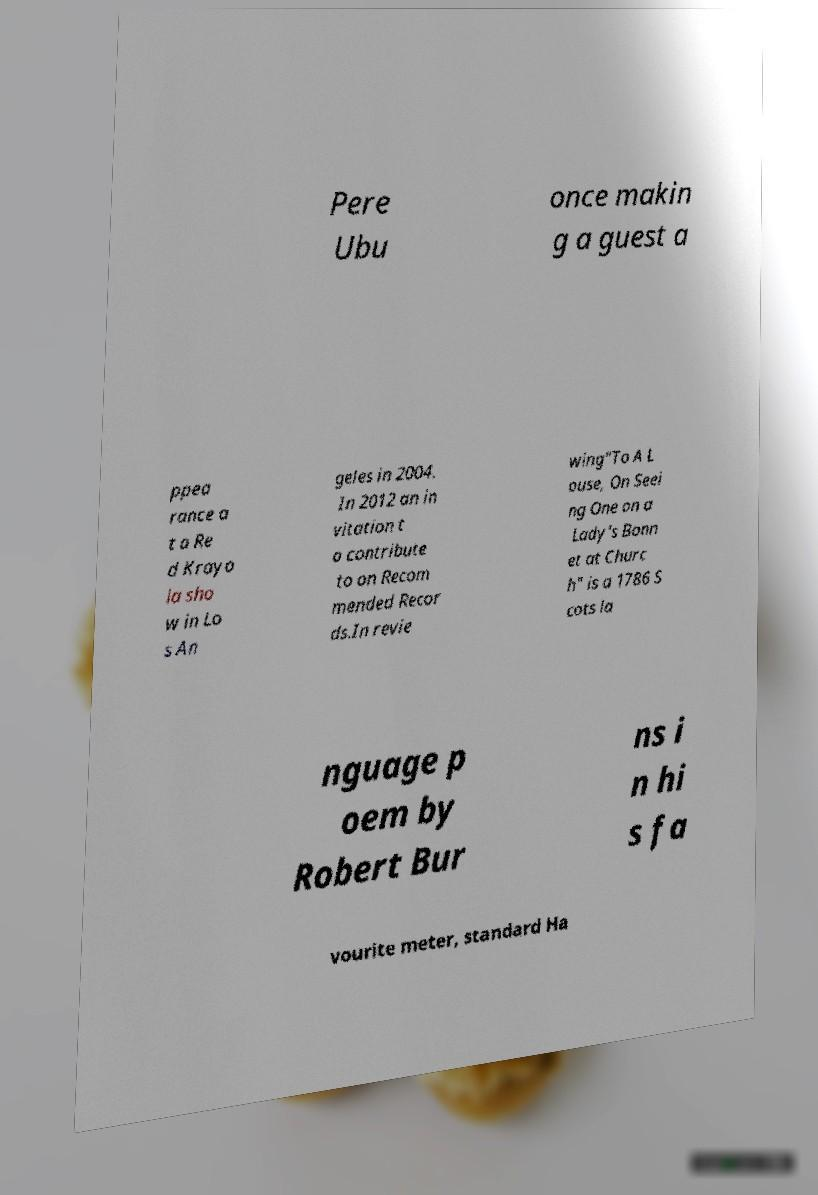Could you assist in decoding the text presented in this image and type it out clearly? Pere Ubu once makin g a guest a ppea rance a t a Re d Krayo la sho w in Lo s An geles in 2004. In 2012 an in vitation t o contribute to on Recom mended Recor ds.In revie wing"To A L ouse, On Seei ng One on a Lady's Bonn et at Churc h" is a 1786 S cots la nguage p oem by Robert Bur ns i n hi s fa vourite meter, standard Ha 